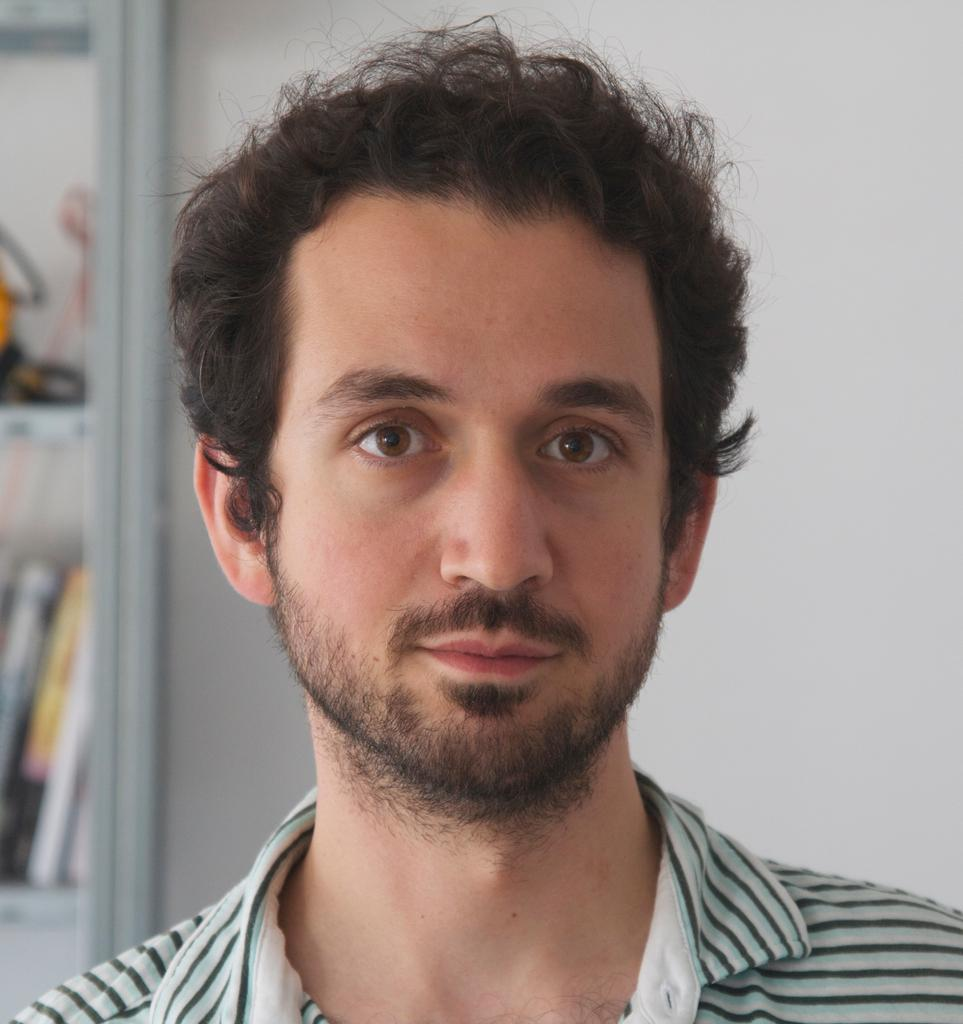Who is present in the image? There is a man in the image. What can be seen in the background of the image? There is a wall and books in the background of the image. What else is visible in the background of the image? There are objects on racks in the background of the image. What degree does the visitor in the image hold? There is no visitor present in the image, and therefore no degree can be attributed to them. 